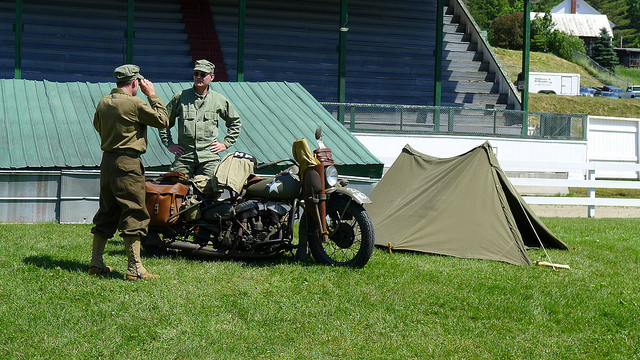Describe the surroundings in which the individuals are located. The image depicts a grassy field, likely part of an outdoor event or re-enactment, given the presence of a contemporary building and seating in the background. There's also a small, military-style canvas tent pitched beside them, adding to the historical re-enactment ambiance. The setting is serene and well-maintained, suggesting a peaceful, non-combat scenario. 